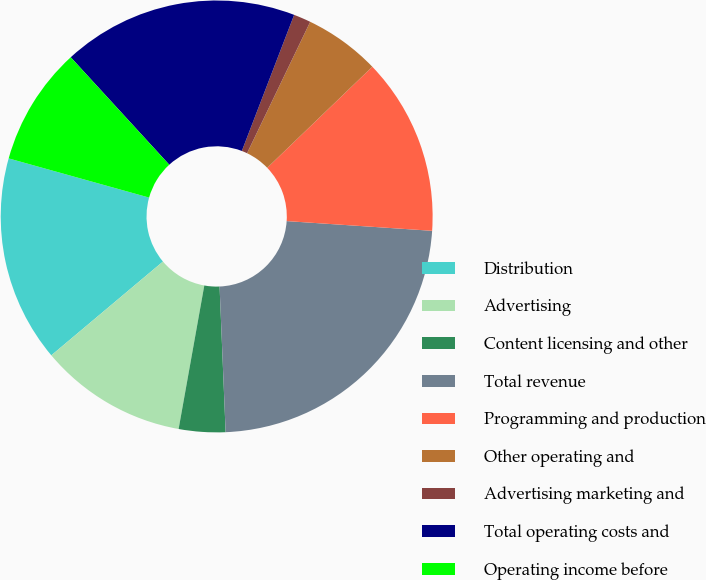Convert chart to OTSL. <chart><loc_0><loc_0><loc_500><loc_500><pie_chart><fcel>Distribution<fcel>Advertising<fcel>Content licensing and other<fcel>Total revenue<fcel>Programming and production<fcel>Other operating and<fcel>Advertising marketing and<fcel>Total operating costs and<fcel>Operating income before<nl><fcel>15.45%<fcel>11.06%<fcel>3.48%<fcel>23.28%<fcel>13.25%<fcel>5.68%<fcel>1.29%<fcel>17.65%<fcel>8.86%<nl></chart> 